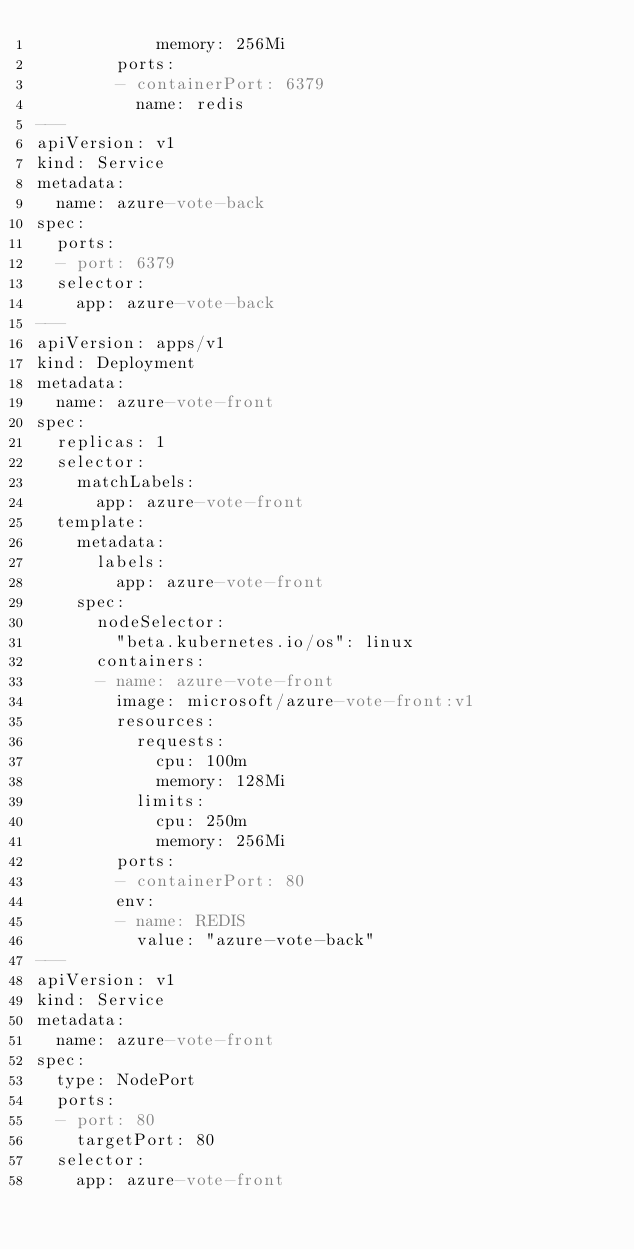Convert code to text. <code><loc_0><loc_0><loc_500><loc_500><_YAML_>            memory: 256Mi
        ports:
        - containerPort: 6379
          name: redis
---
apiVersion: v1
kind: Service
metadata:
  name: azure-vote-back
spec:
  ports:
  - port: 6379
  selector:
    app: azure-vote-back
---
apiVersion: apps/v1
kind: Deployment
metadata:
  name: azure-vote-front
spec:
  replicas: 1
  selector:
    matchLabels:
      app: azure-vote-front
  template:
    metadata:
      labels:
        app: azure-vote-front
    spec:
      nodeSelector:
        "beta.kubernetes.io/os": linux
      containers:
      - name: azure-vote-front
        image: microsoft/azure-vote-front:v1
        resources:
          requests:
            cpu: 100m
            memory: 128Mi
          limits:
            cpu: 250m
            memory: 256Mi
        ports:
        - containerPort: 80
        env:
        - name: REDIS
          value: "azure-vote-back"
---
apiVersion: v1
kind: Service
metadata:
  name: azure-vote-front
spec:
  type: NodePort
  ports:
  - port: 80
    targetPort: 80
  selector:
    app: azure-vote-front
</code> 